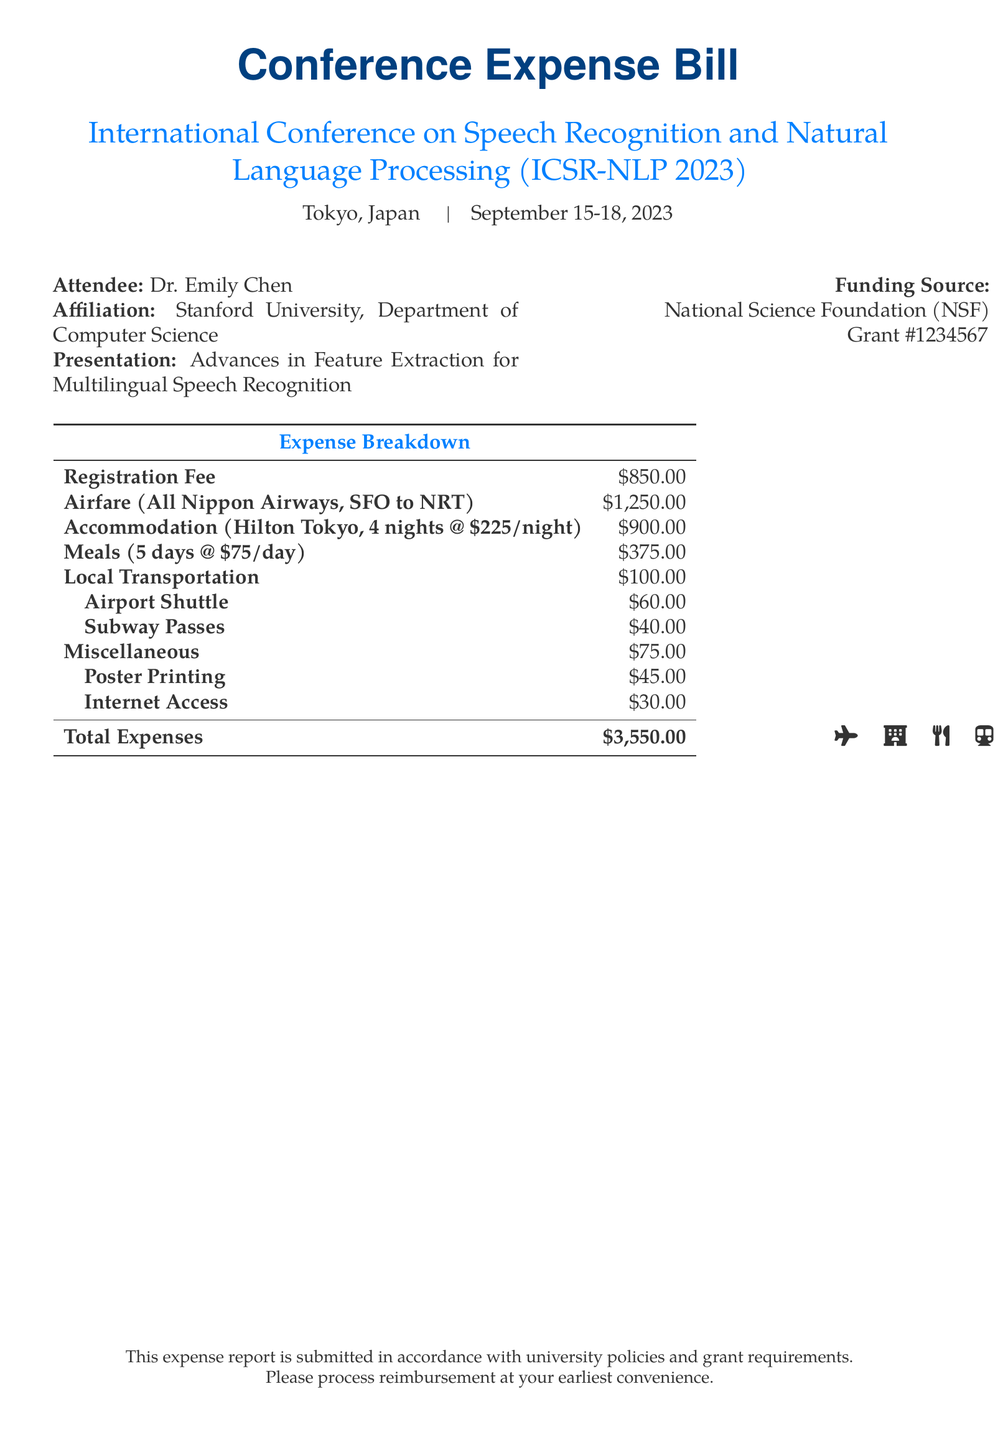What is the total cost of airfare? The airfare is specifically listed as $1,250.00 in the expense breakdown.
Answer: $1,250.00 Who is the attendee of the conference? The name of the attendee is listed as Dr. Emily Chen in the document.
Answer: Dr. Emily Chen What is the name of the conference? The conference title is mentioned as International Conference on Speech Recognition and Natural Language Processing.
Answer: International Conference on Speech Recognition and Natural Language Processing What is the accommodation cost? The document specifies the accommodation cost as $900.00 for 4 nights at $225 per night.
Answer: $900.00 How many days were meals accounted for? Meals are accounted for over a period of 5 days as indicated in the expenses.
Answer: 5 days What is the funding source for the conference attendance? The funding source is detailed in the document as the National Science Foundation.
Answer: National Science Foundation What was the total expense amount? The total expenses, calculated from the provided breakdown, is $3,550.00.
Answer: $3,550.00 What type of transportation was used locally? Local transportation expenses include an airport shuttle and subway passes as specified in the document.
Answer: Airport Shuttle and Subway Passes What is the role of Dr. Emily Chen at Stanford University? The document states that Dr. Emily Chen is affiliated with the Department of Computer Science at Stanford University.
Answer: Department of Computer Science 